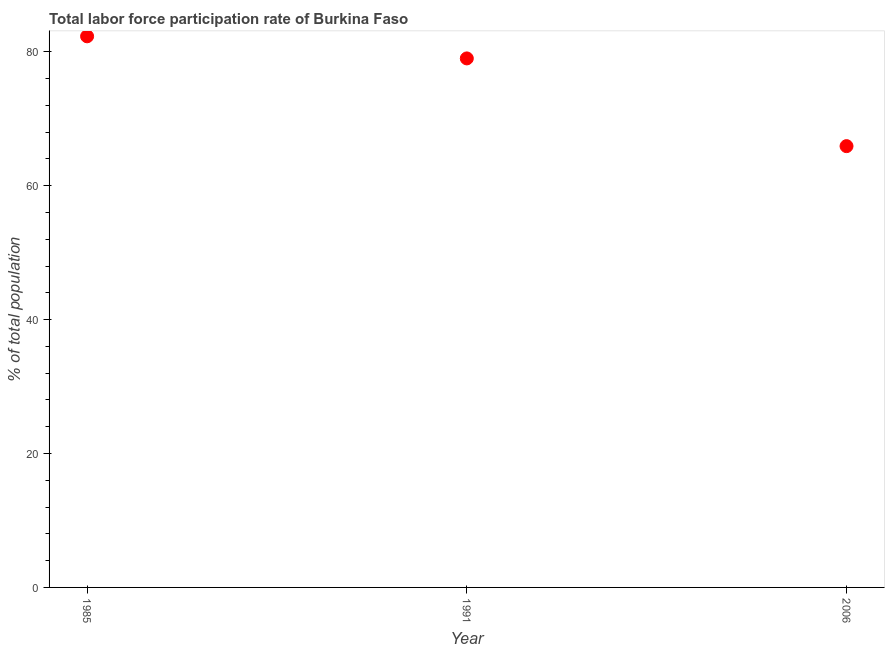What is the total labor force participation rate in 1991?
Provide a succinct answer. 79. Across all years, what is the maximum total labor force participation rate?
Your answer should be compact. 82.3. Across all years, what is the minimum total labor force participation rate?
Your answer should be compact. 65.9. In which year was the total labor force participation rate maximum?
Keep it short and to the point. 1985. What is the sum of the total labor force participation rate?
Offer a terse response. 227.2. What is the difference between the total labor force participation rate in 1985 and 2006?
Offer a very short reply. 16.4. What is the average total labor force participation rate per year?
Your answer should be compact. 75.73. What is the median total labor force participation rate?
Give a very brief answer. 79. Do a majority of the years between 1991 and 1985 (inclusive) have total labor force participation rate greater than 36 %?
Your answer should be compact. No. What is the ratio of the total labor force participation rate in 1985 to that in 1991?
Keep it short and to the point. 1.04. Is the total labor force participation rate in 1985 less than that in 2006?
Give a very brief answer. No. What is the difference between the highest and the second highest total labor force participation rate?
Keep it short and to the point. 3.3. What is the difference between the highest and the lowest total labor force participation rate?
Ensure brevity in your answer.  16.4. Does the total labor force participation rate monotonically increase over the years?
Offer a terse response. No. How many dotlines are there?
Keep it short and to the point. 1. Does the graph contain any zero values?
Provide a short and direct response. No. What is the title of the graph?
Provide a short and direct response. Total labor force participation rate of Burkina Faso. What is the label or title of the Y-axis?
Your answer should be compact. % of total population. What is the % of total population in 1985?
Make the answer very short. 82.3. What is the % of total population in 1991?
Make the answer very short. 79. What is the % of total population in 2006?
Offer a very short reply. 65.9. What is the difference between the % of total population in 1985 and 1991?
Make the answer very short. 3.3. What is the difference between the % of total population in 1985 and 2006?
Your response must be concise. 16.4. What is the ratio of the % of total population in 1985 to that in 1991?
Make the answer very short. 1.04. What is the ratio of the % of total population in 1985 to that in 2006?
Provide a short and direct response. 1.25. What is the ratio of the % of total population in 1991 to that in 2006?
Make the answer very short. 1.2. 